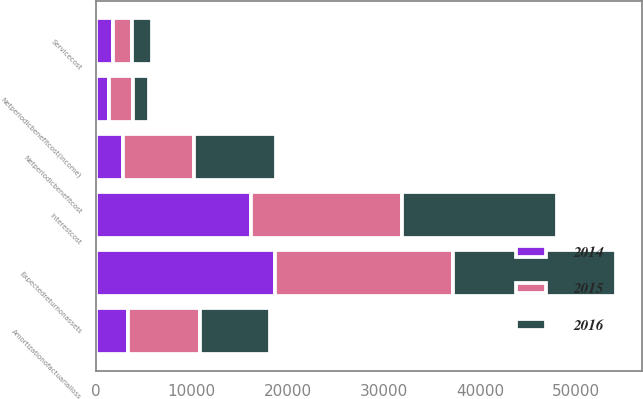Convert chart to OTSL. <chart><loc_0><loc_0><loc_500><loc_500><stacked_bar_chart><ecel><fcel>Servicecost<fcel>Interestcost<fcel>Expectedreturnonassets<fcel>Amortizationofactuarialloss<fcel>Netperiodicbenefitcost<fcel>Netperiodicbenefitcost(income)<nl><fcel>2016<fcel>2100<fcel>16106<fcel>17013<fcel>7361<fcel>8554<fcel>1707<nl><fcel>2015<fcel>1918<fcel>15683<fcel>18538<fcel>7468<fcel>7377<fcel>2425<nl><fcel>2014<fcel>1824<fcel>16209<fcel>18631<fcel>3351<fcel>2851<fcel>1423<nl></chart> 